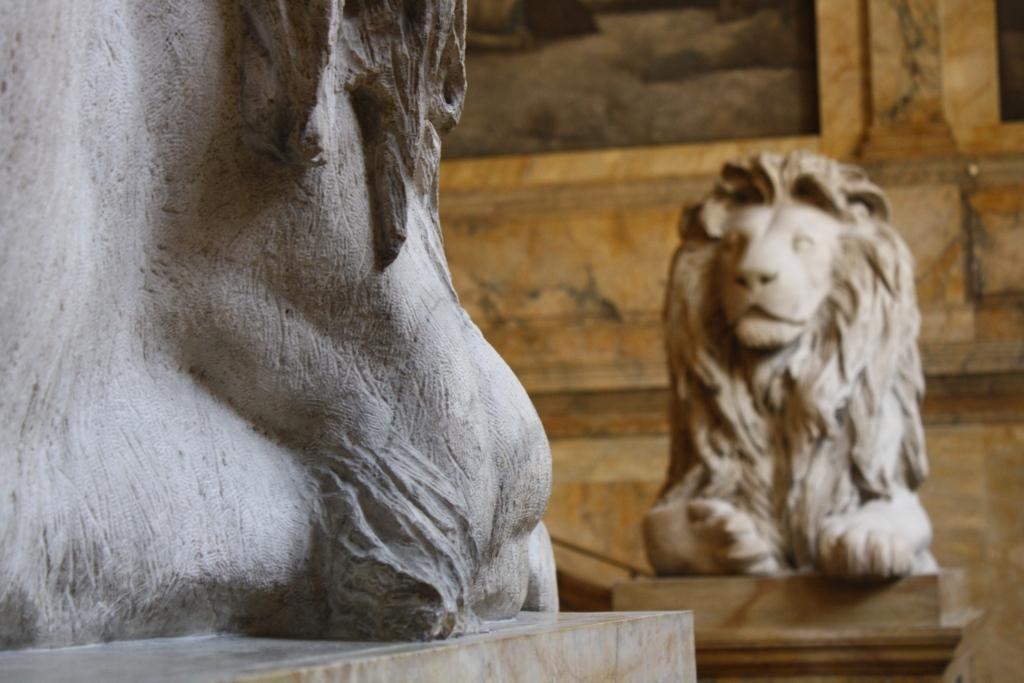In one or two sentences, can you explain what this image depicts? In this image on the left side there is a sculpture, and on the right side of the image there is a sculpture. And in the background there is wall and there might be some objects on the wall. 